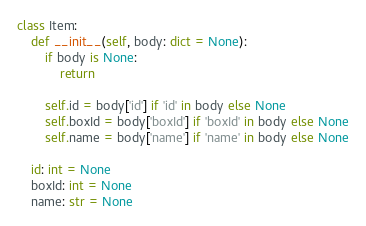Convert code to text. <code><loc_0><loc_0><loc_500><loc_500><_Python_>class Item:
    def __init__(self, body: dict = None):
        if body is None:
            return

        self.id = body['id'] if 'id' in body else None
        self.boxId = body['boxId'] if 'boxId' in body else None
        self.name = body['name'] if 'name' in body else None

    id: int = None
    boxId: int = None
    name: str = None
</code> 